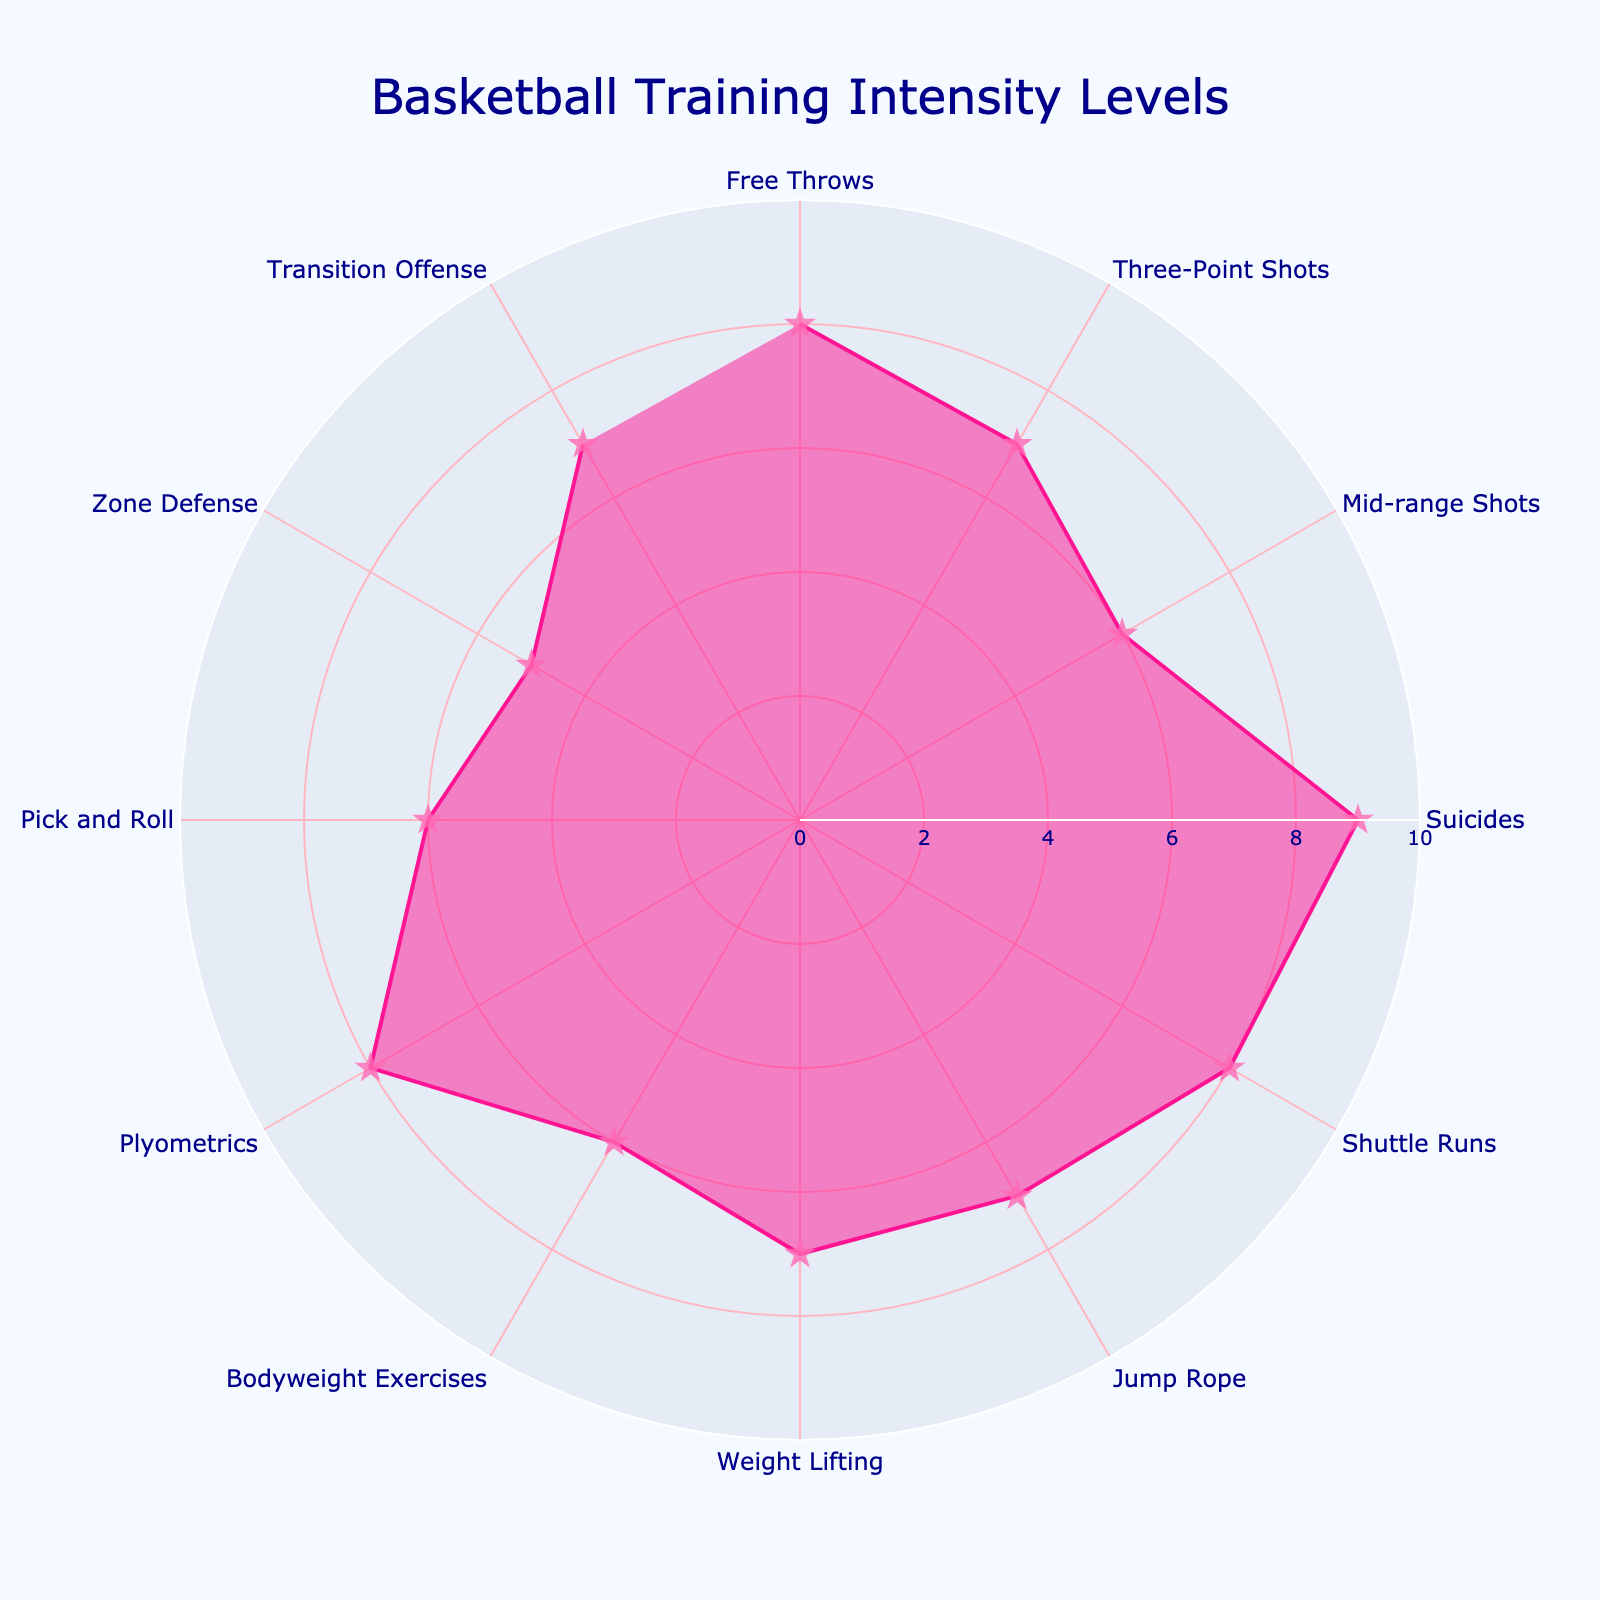What's the title of the chart? The title of the chart is a textual element typically located at the top of the figure. It provides context about the content of the chart by summarizing its main topic.
Answer: Basketball Training Intensity Levels What is the highest intensity level shown, and for which drill? To find the highest intensity level, look at the filled area extending furthest from the center. Identify the drill corresponding to this value.
Answer: Suicides (9) How many drills have an intensity level of 7? Count the number of drills listed in the Polar Chart that have their intensity level at 7.
Answer: 4 What is the average intensity level of the shooting drills? Calculate the average by summing the intensity levels for Free Throws (8), Three-Point Shots (7), and Mid-range Shots (6); then divide by the number of shooting drills. (8+7+6)/3 = 21/3
Answer: 7 Which conditioning drill has the lowest intensity level, and what is that level? Among the conditioning drills Suicides, Shuttle Runs, and Jump Rope, identify the drill with the lowest radial extension.
Answer: Jump Rope (7) Compare the intensity level of Zone Defense and Transition Offense. Which one is higher? Locate the data points for both Zone Defense and Transition Offense. Compare their intensity levels.
Answer: Transition Offense (7) What is the total intensity value of the strength training drills? Add the intensity levels for Weight Lifting (7), Bodyweight Exercises (6), and Plyometrics (8). 7+6+8 = 21.
Answer: 21 Which drill has the same intensity as Weight Lifting? Identify the drill type and its corresponding intensity level. Find another drill with an equivalent intensity level.
Answer: Three-Point Shots Identify all drills with an intensity level of 6. List all drills where the radial extension reaches the tick mark indicating the intensity level of 6.
Answer: Mid-range Shots, Bodyweight Exercises, Pick and Roll Which Tactical Play drill has the highest intensity level and what is the value? Examine the Tactical Plays section and identify the drill with the highest radial extension.
Answer: Transition Offense (7) 